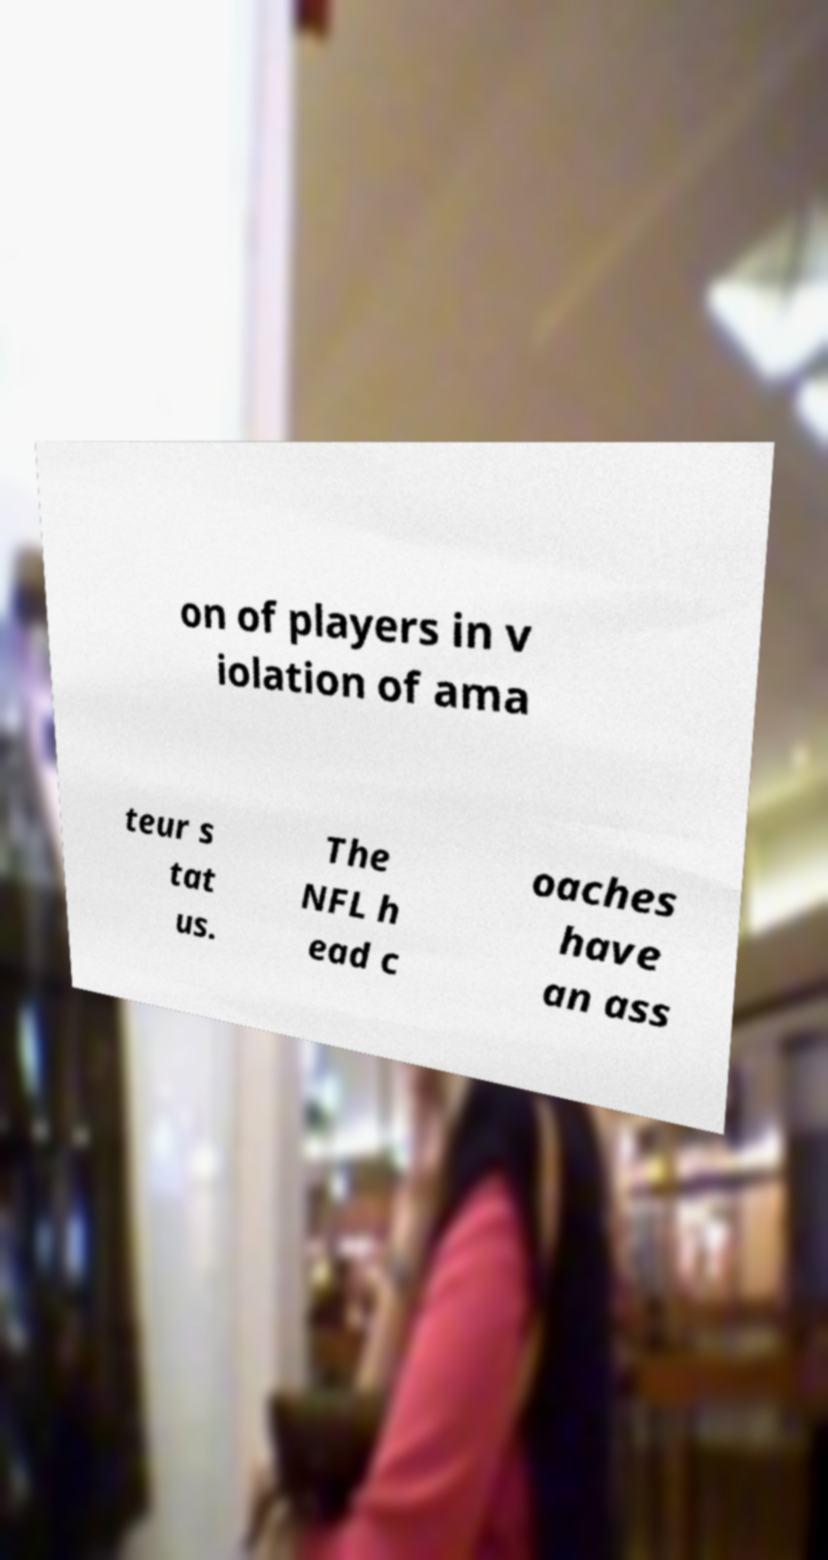Please identify and transcribe the text found in this image. on of players in v iolation of ama teur s tat us. The NFL h ead c oaches have an ass 